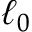Convert formula to latex. <formula><loc_0><loc_0><loc_500><loc_500>\ell _ { 0 }</formula> 